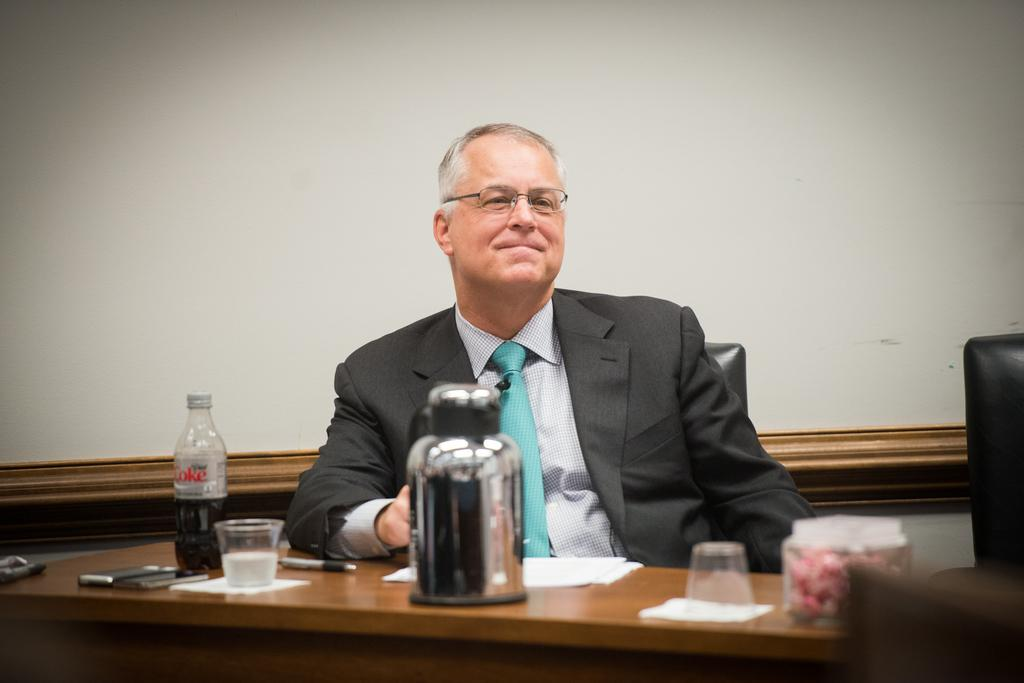What is the man doing in the image? The man is sitting on a chair in the image. What is in front of the man? The man is in front of a table. What objects can be seen on the table? There is a kettle, a bottle, and glasses on the table. Can you describe the man's appearance? The man is wearing spectacles. What is visible in the background of the image? There is a wall in the background. Is there a slope visible in the image? No, there is no slope present in the image. Can you see a fan in the image? No, there is no fan present in the image. 